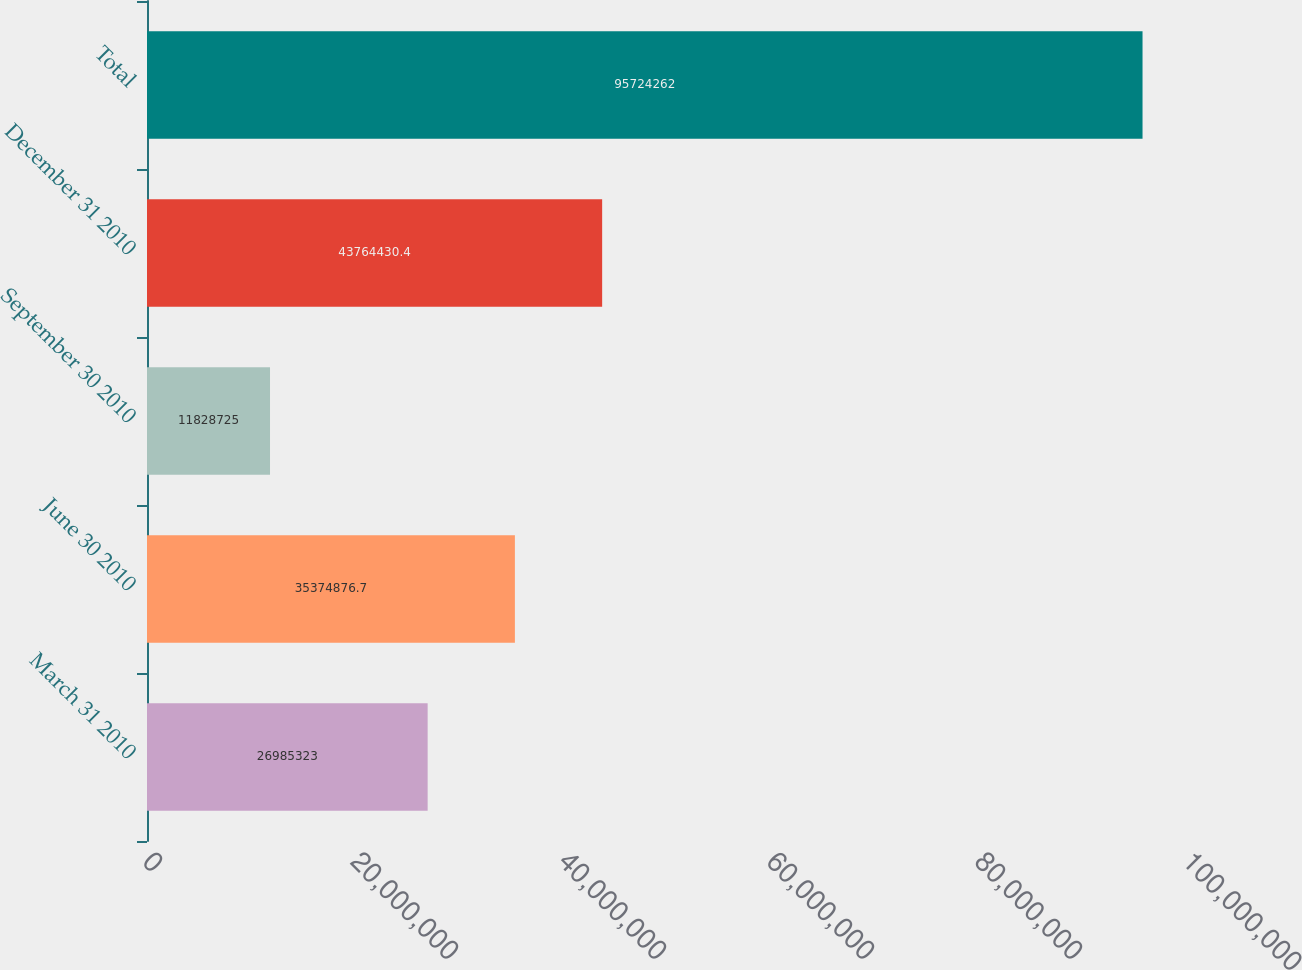<chart> <loc_0><loc_0><loc_500><loc_500><bar_chart><fcel>March 31 2010<fcel>June 30 2010<fcel>September 30 2010<fcel>December 31 2010<fcel>Total<nl><fcel>2.69853e+07<fcel>3.53749e+07<fcel>1.18287e+07<fcel>4.37644e+07<fcel>9.57243e+07<nl></chart> 